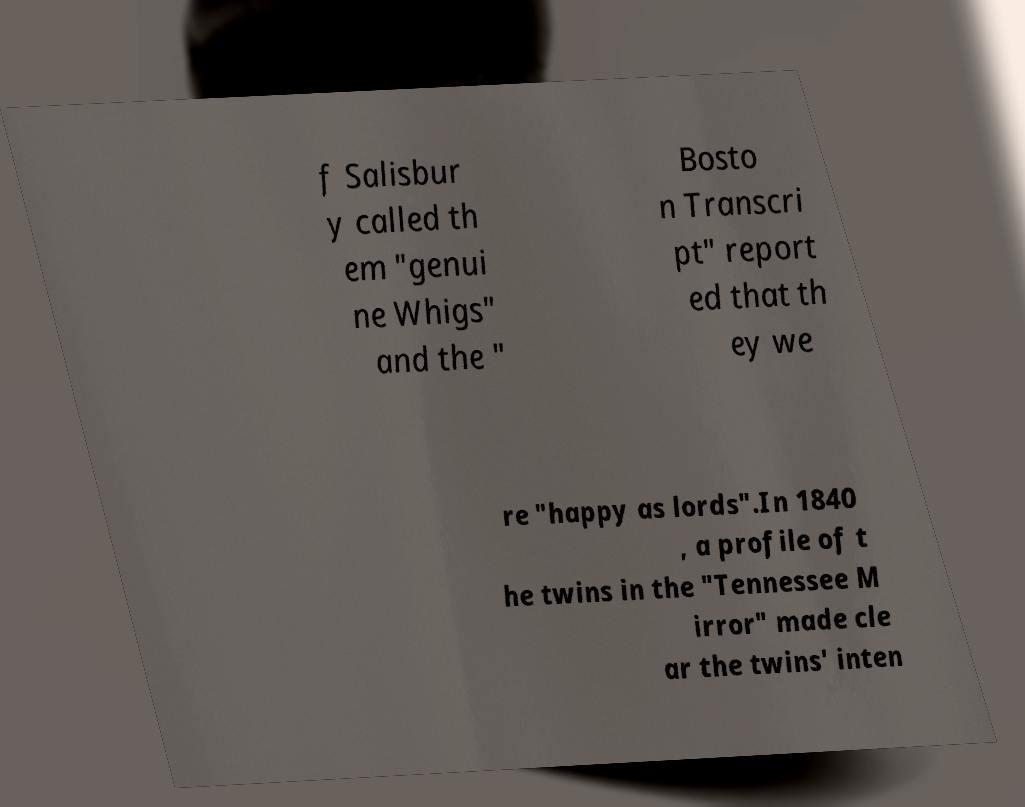Could you extract and type out the text from this image? f Salisbur y called th em "genui ne Whigs" and the " Bosto n Transcri pt" report ed that th ey we re "happy as lords".In 1840 , a profile of t he twins in the "Tennessee M irror" made cle ar the twins' inten 